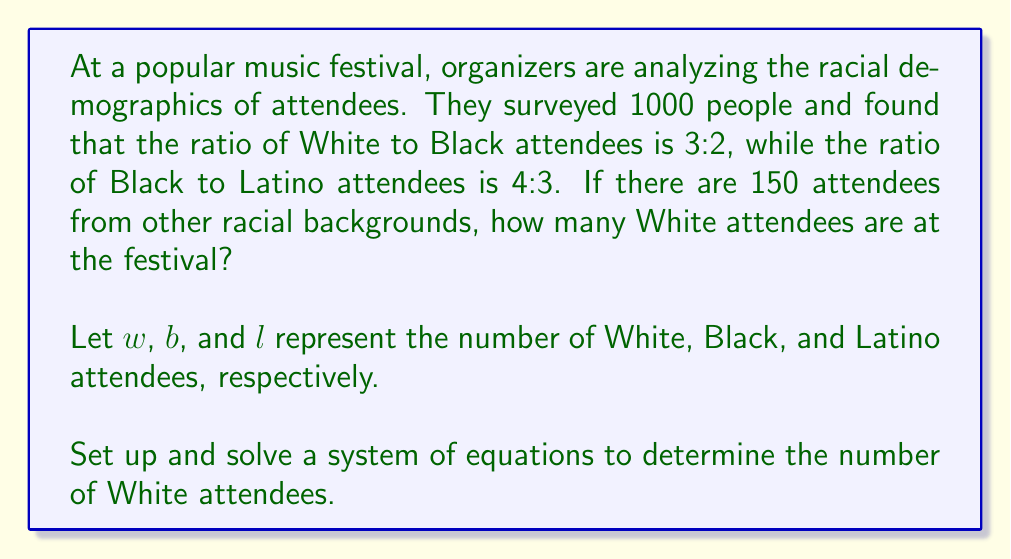Could you help me with this problem? Let's approach this step-by-step:

1) First, we can set up equations based on the given ratios:
   
   $$\frac{w}{b} = \frac{3}{2}$$ (White to Black ratio)
   $$\frac{b}{l} = \frac{4}{3}$$ (Black to Latino ratio)

2) We also know that the total number of attendees is 1000, and 150 of them are from other racial backgrounds. So:

   $$w + b + l + 150 = 1000$$

3) From the first ratio, we can express $w$ in terms of $b$:
   
   $$w = \frac{3}{2}b$$

4) From the second ratio, we can express $l$ in terms of $b$:
   
   $$l = \frac{3}{4}b$$

5) Now, let's substitute these into our total attendees equation:

   $$\frac{3}{2}b + b + \frac{3}{4}b + 150 = 1000$$

6) Simplify:

   $$\frac{13}{4}b + 150 = 1000$$

7) Subtract 150 from both sides:

   $$\frac{13}{4}b = 850$$

8) Multiply both sides by $\frac{4}{13}$:

   $$b = 850 \cdot \frac{4}{13} = \frac{3400}{13} \approx 261.54$$

9) Since we can't have a fractional number of people, we round down to 261 Black attendees.

10) Now we can find the number of White attendees:

    $$w = \frac{3}{2}b = \frac{3}{2} \cdot 261 = 391.5$$

11) Again, we round down to 391 White attendees.
Answer: There are 391 White attendees at the music festival. 